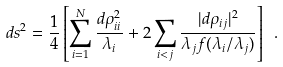<formula> <loc_0><loc_0><loc_500><loc_500>d s ^ { 2 } = \frac { 1 } { 4 } \left [ \sum _ { i = 1 } ^ { N } \frac { d \rho _ { i i } ^ { 2 } } { \lambda _ { i } } + 2 \sum _ { i < j } \frac { | d \rho _ { i j } | ^ { 2 } } { \lambda _ { j } f ( \lambda _ { i } / \lambda _ { j } ) } \right ] \ .</formula> 